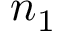Convert formula to latex. <formula><loc_0><loc_0><loc_500><loc_500>n _ { 1 }</formula> 